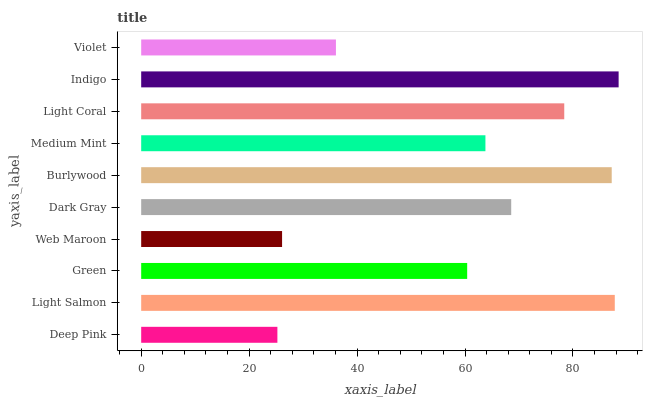Is Deep Pink the minimum?
Answer yes or no. Yes. Is Indigo the maximum?
Answer yes or no. Yes. Is Light Salmon the minimum?
Answer yes or no. No. Is Light Salmon the maximum?
Answer yes or no. No. Is Light Salmon greater than Deep Pink?
Answer yes or no. Yes. Is Deep Pink less than Light Salmon?
Answer yes or no. Yes. Is Deep Pink greater than Light Salmon?
Answer yes or no. No. Is Light Salmon less than Deep Pink?
Answer yes or no. No. Is Dark Gray the high median?
Answer yes or no. Yes. Is Medium Mint the low median?
Answer yes or no. Yes. Is Web Maroon the high median?
Answer yes or no. No. Is Green the low median?
Answer yes or no. No. 